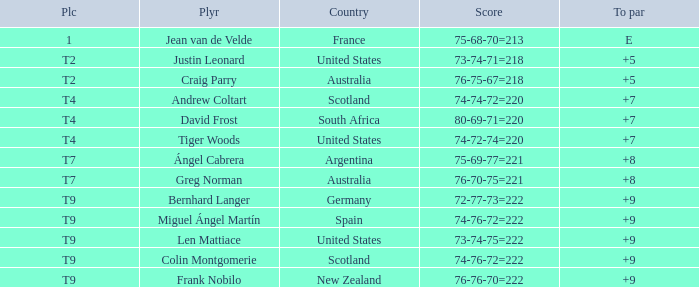What is the To Par score for the player from South Africa? 7.0. 